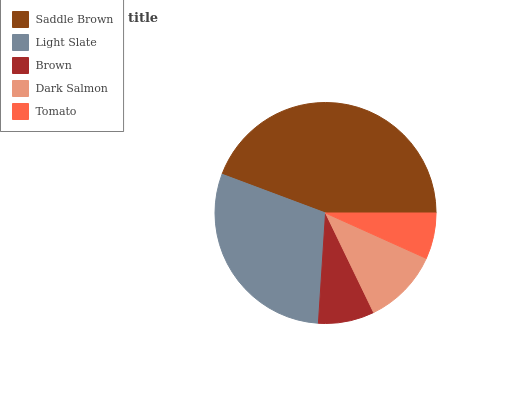Is Tomato the minimum?
Answer yes or no. Yes. Is Saddle Brown the maximum?
Answer yes or no. Yes. Is Light Slate the minimum?
Answer yes or no. No. Is Light Slate the maximum?
Answer yes or no. No. Is Saddle Brown greater than Light Slate?
Answer yes or no. Yes. Is Light Slate less than Saddle Brown?
Answer yes or no. Yes. Is Light Slate greater than Saddle Brown?
Answer yes or no. No. Is Saddle Brown less than Light Slate?
Answer yes or no. No. Is Dark Salmon the high median?
Answer yes or no. Yes. Is Dark Salmon the low median?
Answer yes or no. Yes. Is Tomato the high median?
Answer yes or no. No. Is Saddle Brown the low median?
Answer yes or no. No. 